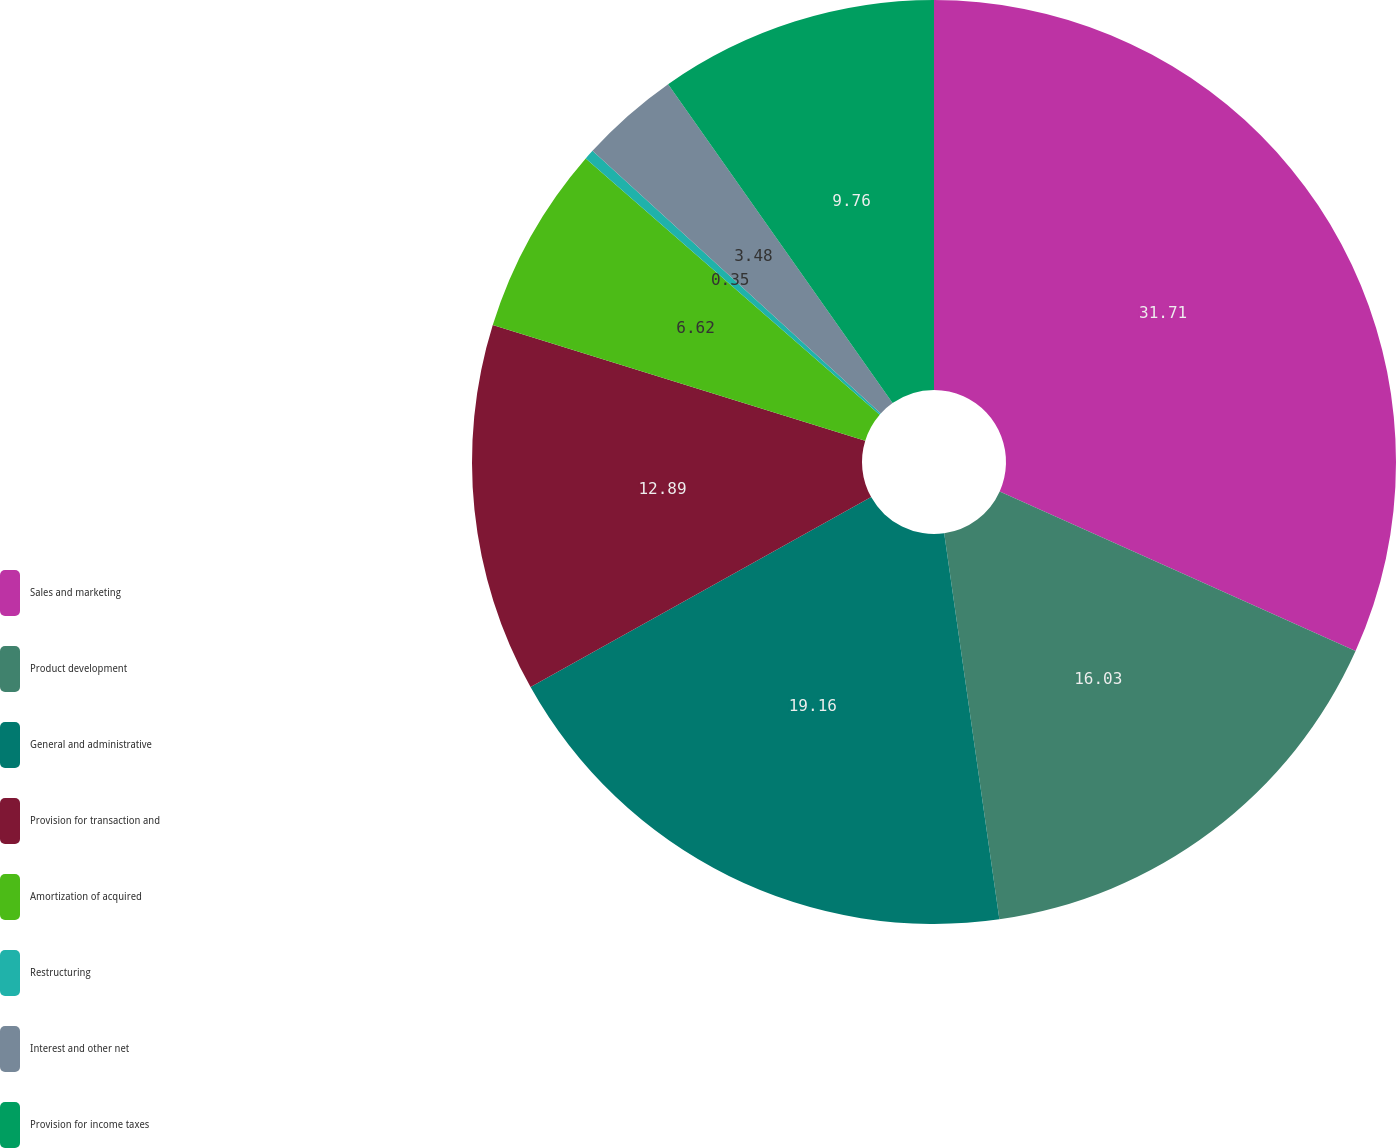Convert chart to OTSL. <chart><loc_0><loc_0><loc_500><loc_500><pie_chart><fcel>Sales and marketing<fcel>Product development<fcel>General and administrative<fcel>Provision for transaction and<fcel>Amortization of acquired<fcel>Restructuring<fcel>Interest and other net<fcel>Provision for income taxes<nl><fcel>31.71%<fcel>16.03%<fcel>19.16%<fcel>12.89%<fcel>6.62%<fcel>0.35%<fcel>3.48%<fcel>9.76%<nl></chart> 